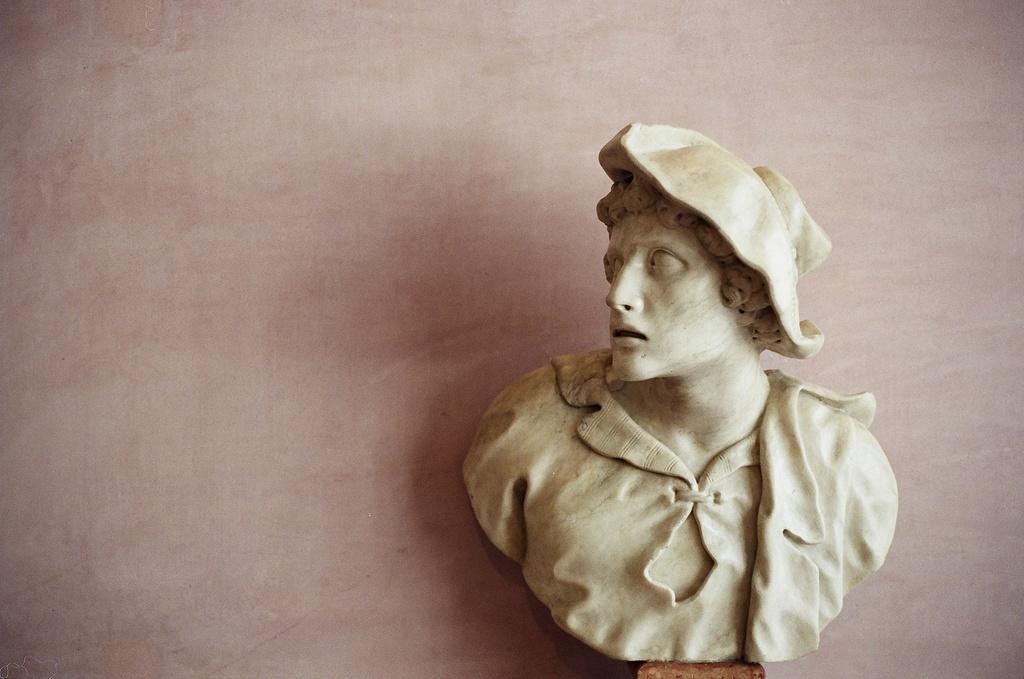Describe this image in one or two sentences. In the picture we can see a sculpture of a half person and in the background we can see a wall. 